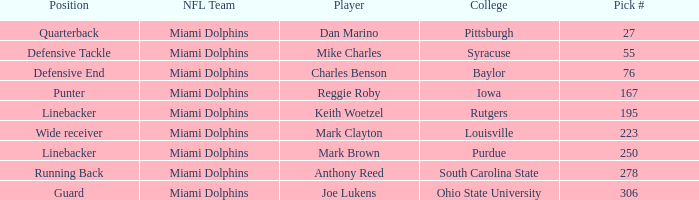Which Position has a Pick # lower than 278 for Player Charles Benson? Defensive End. 